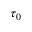Convert formula to latex. <formula><loc_0><loc_0><loc_500><loc_500>\tau _ { 0 }</formula> 